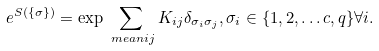Convert formula to latex. <formula><loc_0><loc_0><loc_500><loc_500>e ^ { S ( \{ \sigma \} ) } & = \exp \sum _ { \ m e a n { i j } } K _ { i j } \delta _ { \sigma _ { i } \sigma _ { j } } , \sigma _ { i } \in \{ 1 , 2 , \dots c , q \} \forall i .</formula> 